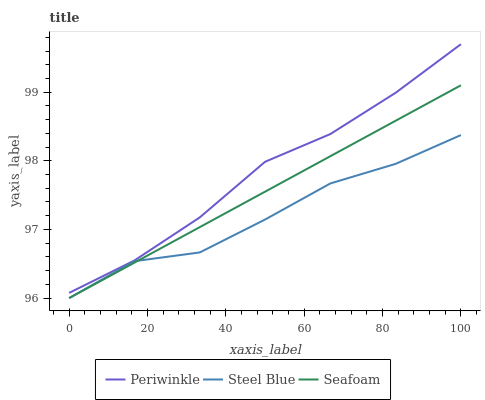Does Seafoam have the minimum area under the curve?
Answer yes or no. No. Does Seafoam have the maximum area under the curve?
Answer yes or no. No. Is Steel Blue the smoothest?
Answer yes or no. No. Is Seafoam the roughest?
Answer yes or no. No. Does Seafoam have the highest value?
Answer yes or no. No. Is Steel Blue less than Periwinkle?
Answer yes or no. Yes. Is Periwinkle greater than Steel Blue?
Answer yes or no. Yes. Does Steel Blue intersect Periwinkle?
Answer yes or no. No. 